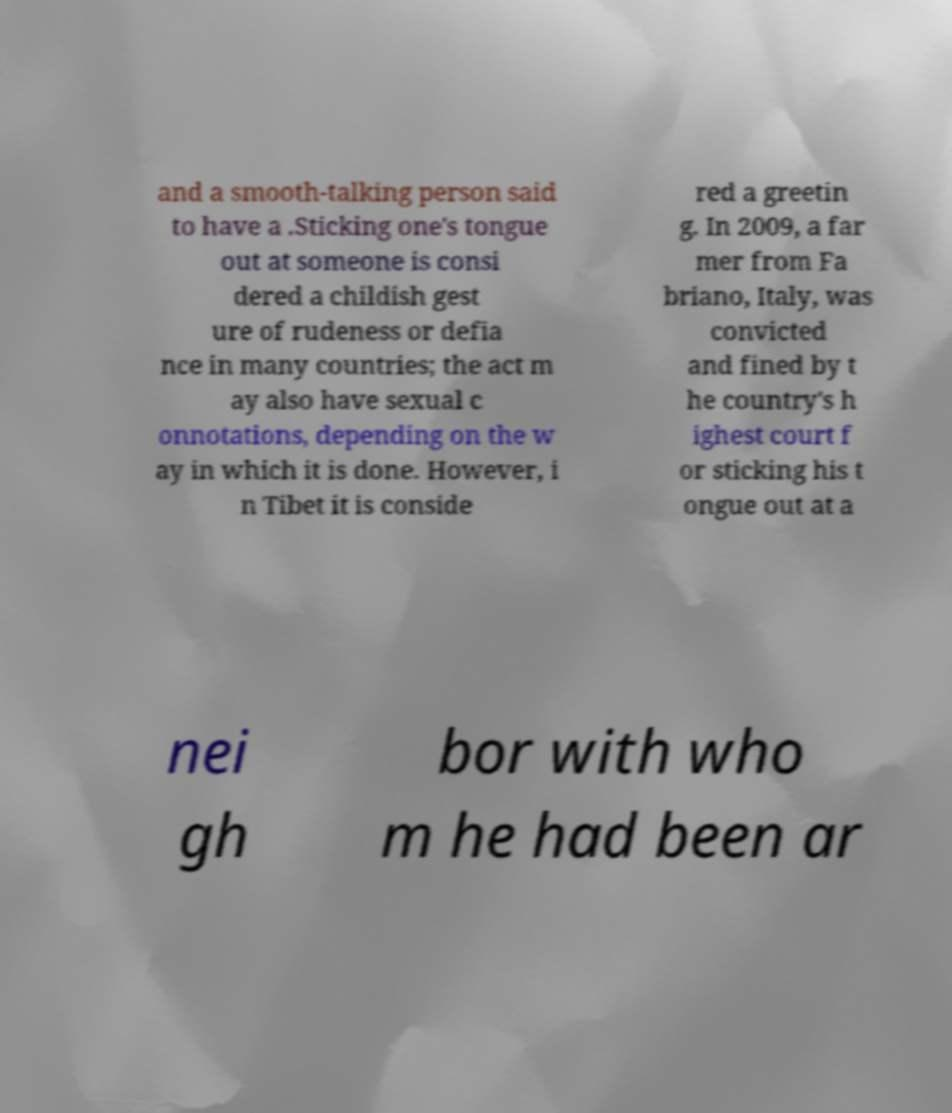Could you assist in decoding the text presented in this image and type it out clearly? and a smooth-talking person said to have a .Sticking one's tongue out at someone is consi dered a childish gest ure of rudeness or defia nce in many countries; the act m ay also have sexual c onnotations, depending on the w ay in which it is done. However, i n Tibet it is conside red a greetin g. In 2009, a far mer from Fa briano, Italy, was convicted and fined by t he country's h ighest court f or sticking his t ongue out at a nei gh bor with who m he had been ar 